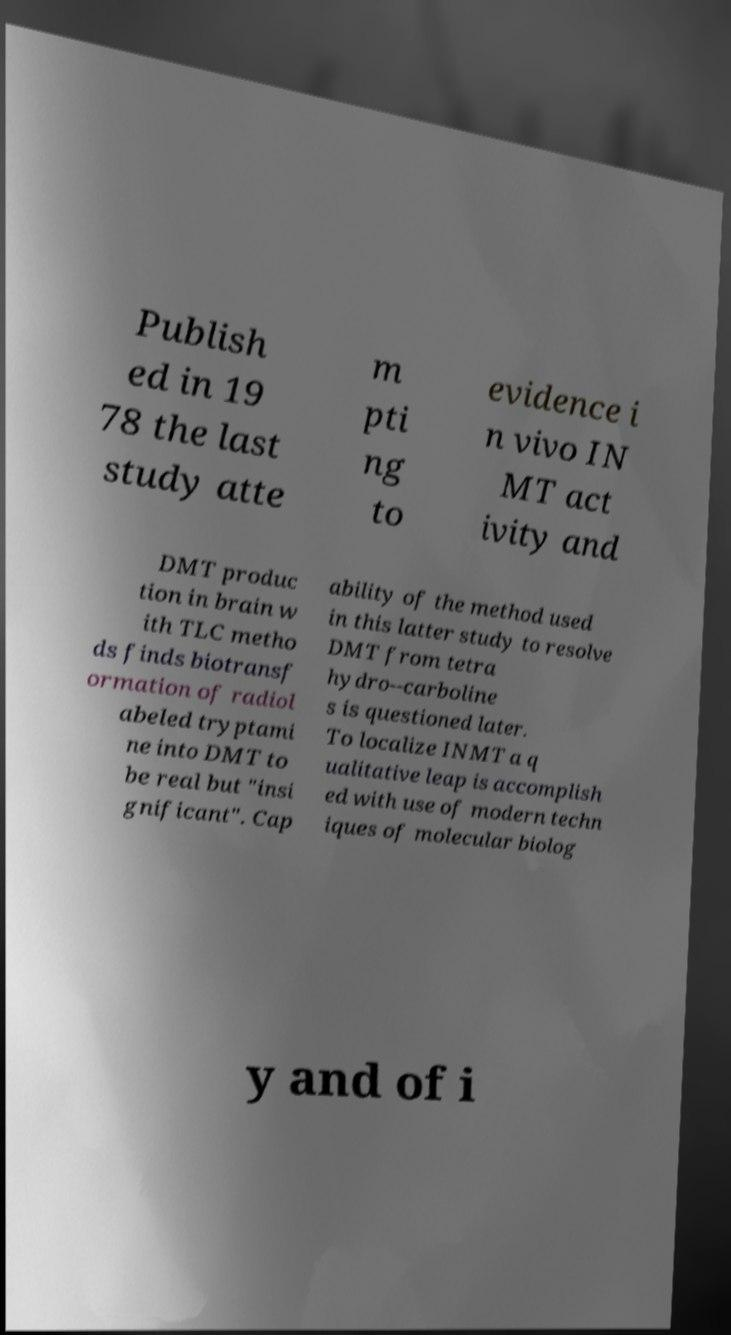Can you read and provide the text displayed in the image?This photo seems to have some interesting text. Can you extract and type it out for me? Publish ed in 19 78 the last study atte m pti ng to evidence i n vivo IN MT act ivity and DMT produc tion in brain w ith TLC metho ds finds biotransf ormation of radiol abeled tryptami ne into DMT to be real but "insi gnificant". Cap ability of the method used in this latter study to resolve DMT from tetra hydro--carboline s is questioned later. To localize INMT a q ualitative leap is accomplish ed with use of modern techn iques of molecular biolog y and of i 